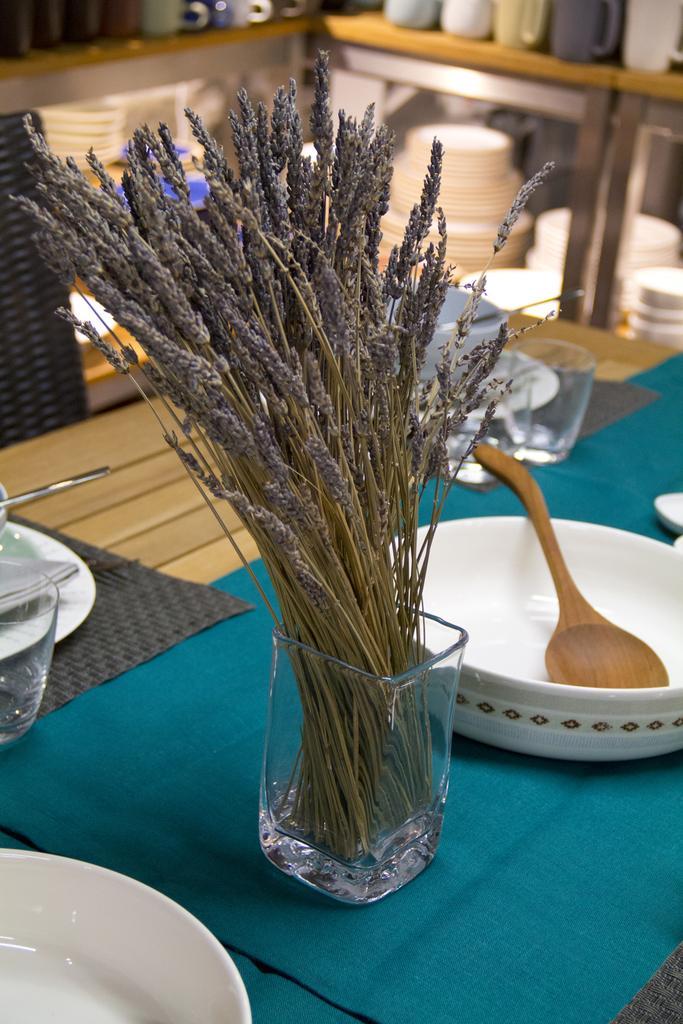How would you summarize this image in a sentence or two? In this image we can see a bowl, flower vase,a plate and a glass which is kept on this table, we can see green colour cloth and a black colour cloth kept on table. In the background we can see a plates which is white in colour and a jars 